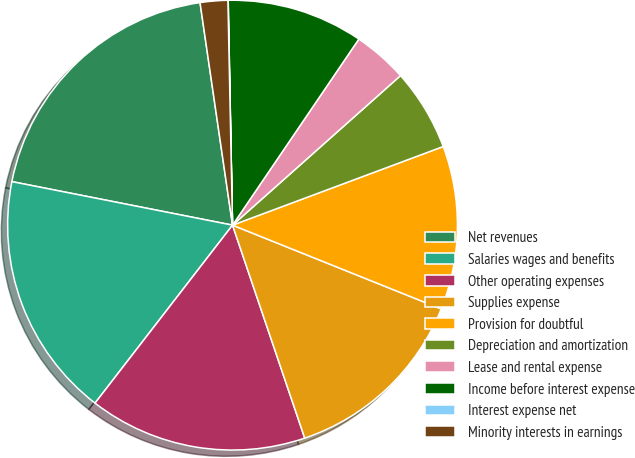Convert chart to OTSL. <chart><loc_0><loc_0><loc_500><loc_500><pie_chart><fcel>Net revenues<fcel>Salaries wages and benefits<fcel>Other operating expenses<fcel>Supplies expense<fcel>Provision for doubtful<fcel>Depreciation and amortization<fcel>Lease and rental expense<fcel>Income before interest expense<fcel>Interest expense net<fcel>Minority interests in earnings<nl><fcel>19.59%<fcel>17.63%<fcel>15.67%<fcel>13.72%<fcel>11.76%<fcel>5.89%<fcel>3.93%<fcel>9.8%<fcel>0.02%<fcel>1.98%<nl></chart> 